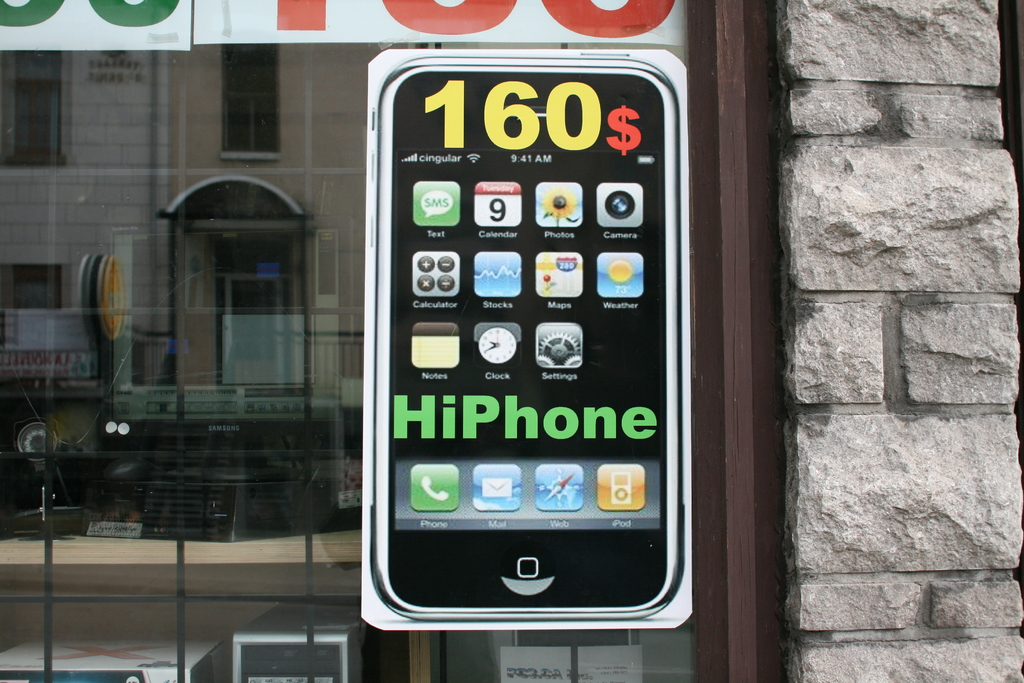How does the use of a large phone model as an advertisement potentially affect consumer interest? Using a large phone model in the advertisement serves as an effective visual attractor, making the product more memorable and stimulating consumer curiosity and attraction by providing a tangible, relatable, and interactive representation of the product. 